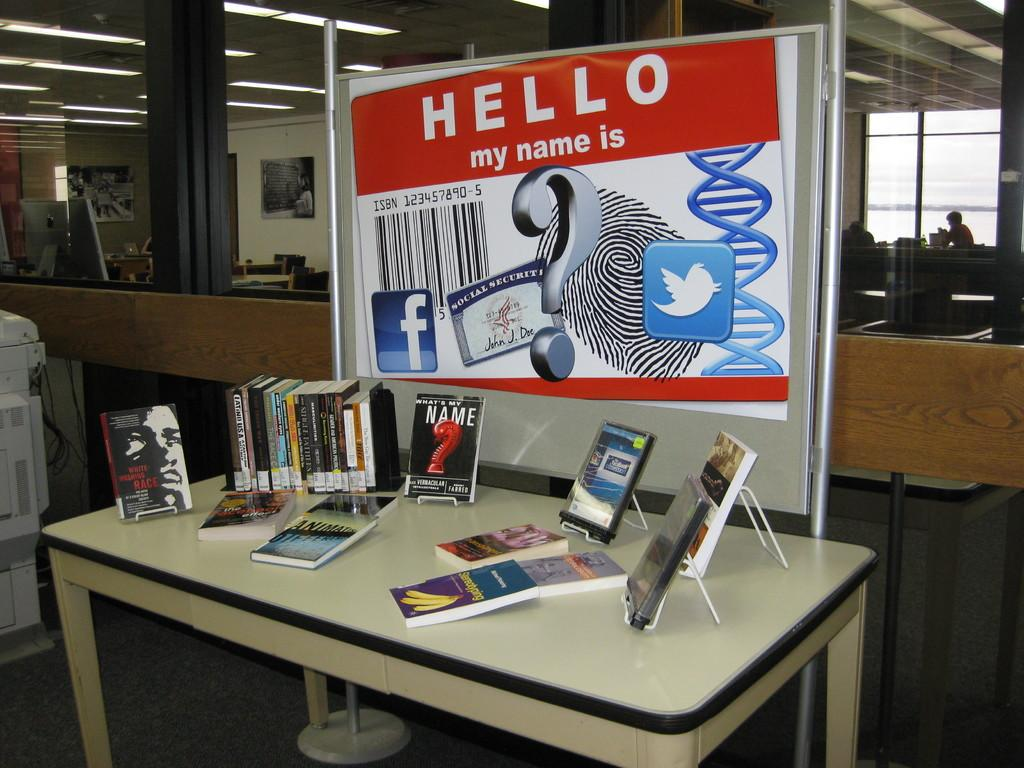<image>
Give a short and clear explanation of the subsequent image. A display behind a table advertises a book called Hello my name is which is on the table. 